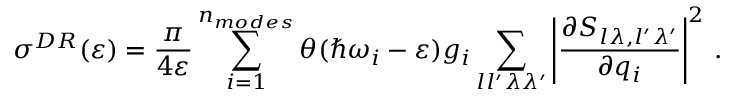Convert formula to latex. <formula><loc_0><loc_0><loc_500><loc_500>\sigma ^ { D R } ( \varepsilon ) = \frac { \pi } { 4 \varepsilon } \sum _ { i = 1 } ^ { n _ { m o d e s } } \theta ( \hbar { \omega } _ { i } - \varepsilon ) g _ { i } \sum _ { l l ^ { \prime } \lambda \lambda ^ { \prime } } \left | \frac { \partial S _ { l \lambda , l ^ { \prime } \lambda ^ { \prime } } } { \partial { q } _ { i } } \right | ^ { 2 } \, .</formula> 